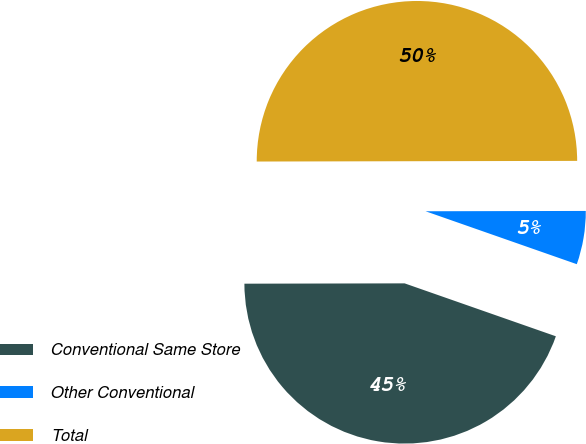Convert chart to OTSL. <chart><loc_0><loc_0><loc_500><loc_500><pie_chart><fcel>Conventional Same Store<fcel>Other Conventional<fcel>Total<nl><fcel>44.61%<fcel>5.39%<fcel>50.0%<nl></chart> 